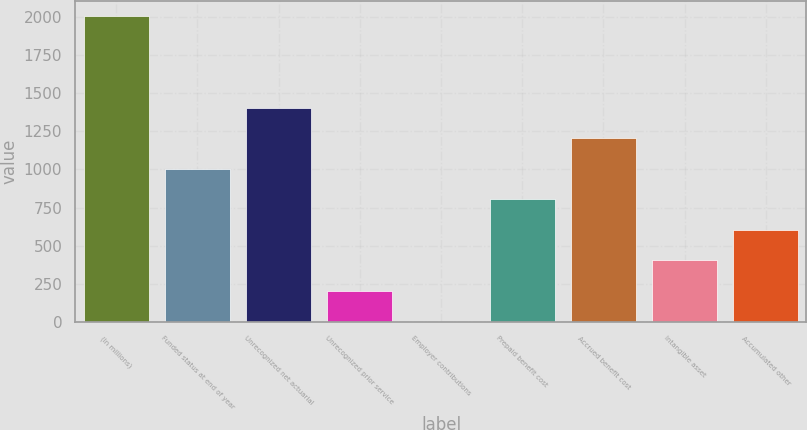Convert chart to OTSL. <chart><loc_0><loc_0><loc_500><loc_500><bar_chart><fcel>(In millions)<fcel>Funded status at end of year<fcel>Unrecognized net actuarial<fcel>Unrecognized prior service<fcel>Employer contributions<fcel>Prepaid benefit cost<fcel>Accrued benefit cost<fcel>Intangible asset<fcel>Accumulated other<nl><fcel>2005<fcel>1004<fcel>1404.4<fcel>203.2<fcel>3<fcel>803.8<fcel>1204.2<fcel>403.4<fcel>603.6<nl></chart> 